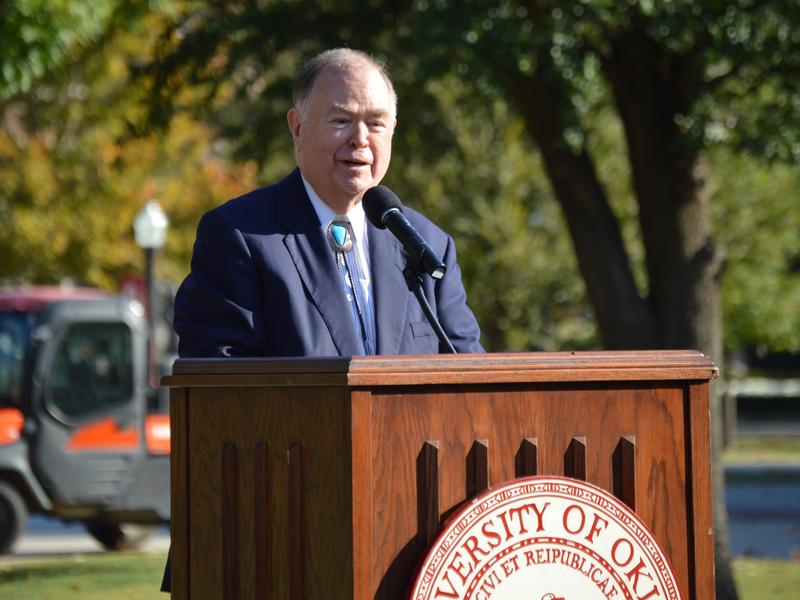Could this event be significant for any specific academic achievement or milestone at the university? Yes, given the formal setting indicated by the podium's seal, this could be a significant event celebrating academic achievements such as groundbreaking research, significant grants received by the university, or notable accomplishments by students or faculty. Such events also serve to inspire and engage the university community, enhancing its academic profile and pride. 